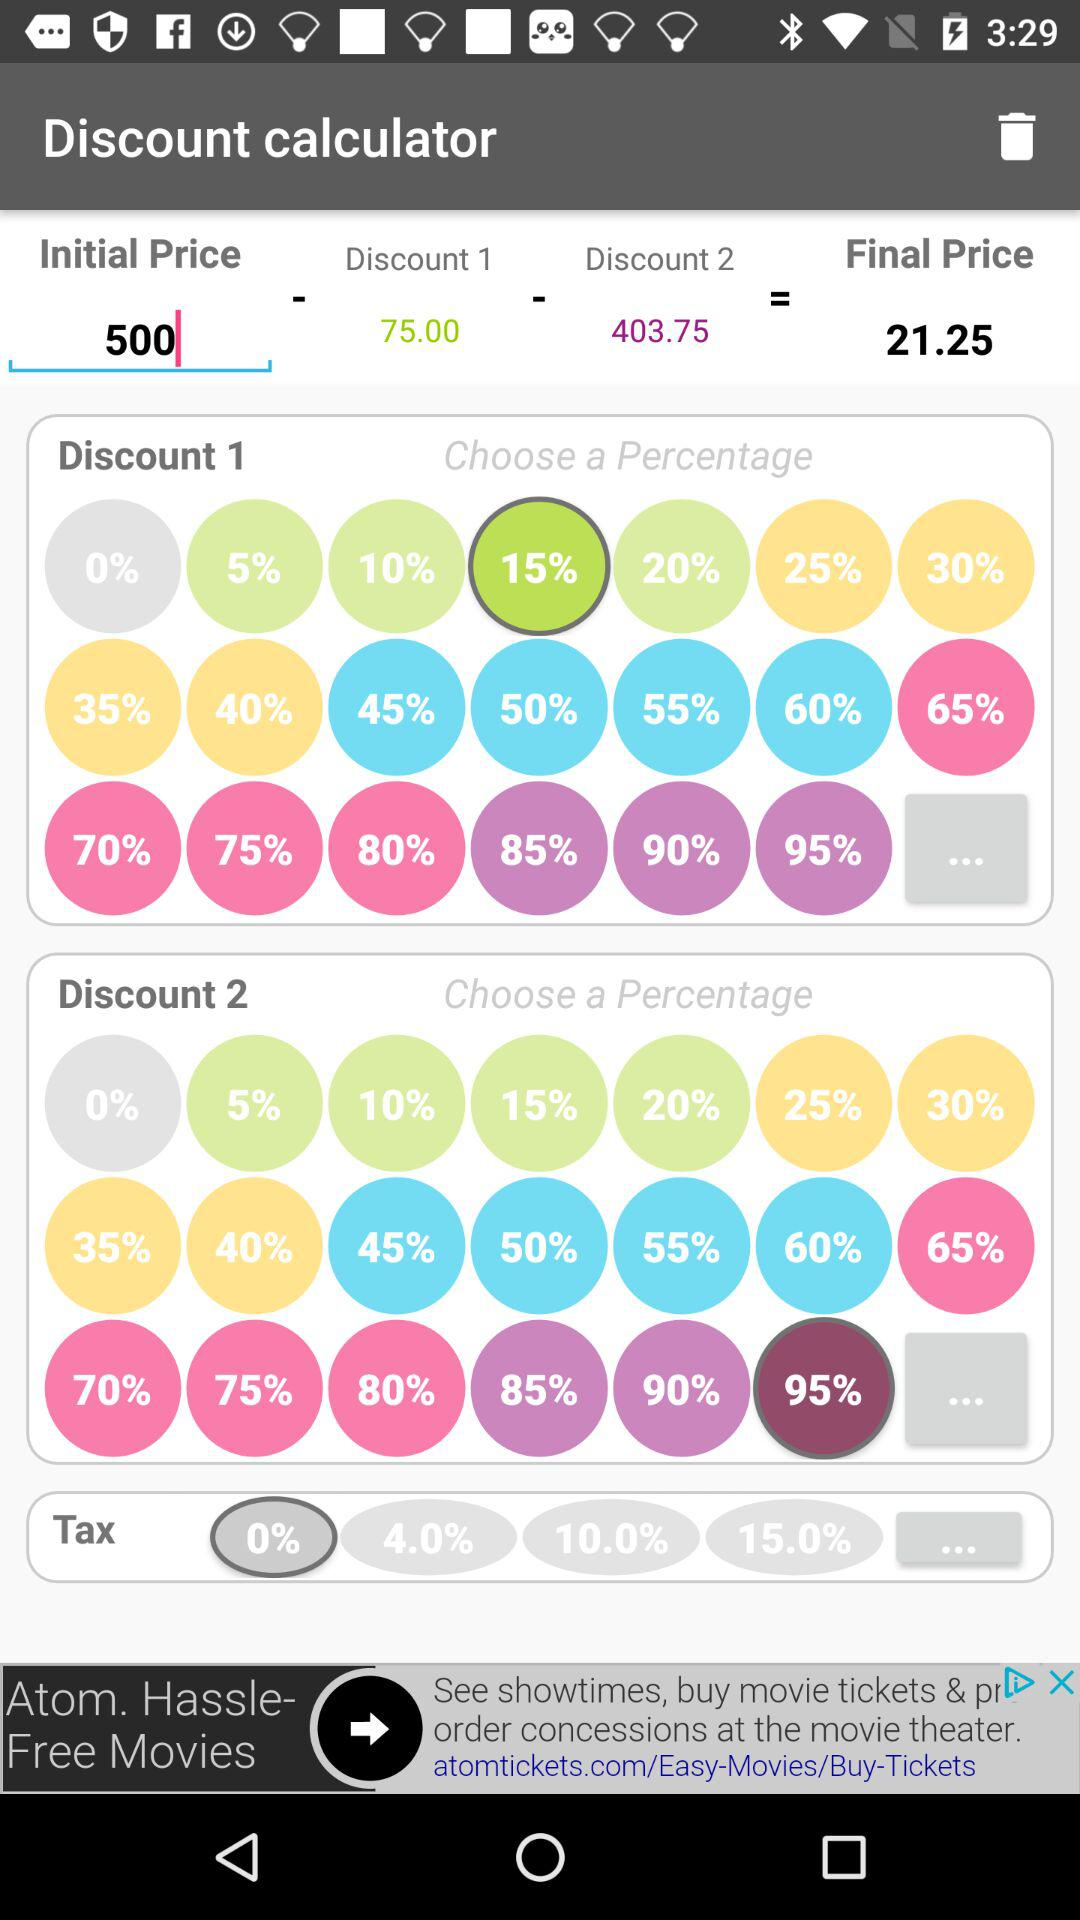What is the initial price? The initial price is 500. 